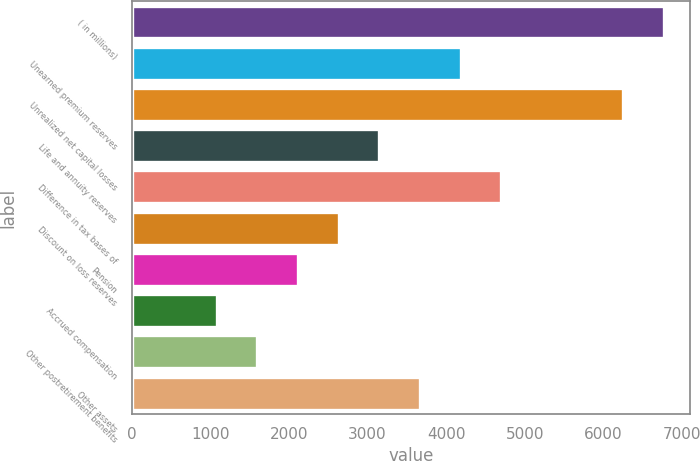<chart> <loc_0><loc_0><loc_500><loc_500><bar_chart><fcel>( in millions)<fcel>Unearned premium reserves<fcel>Unrealized net capital losses<fcel>Life and annuity reserves<fcel>Difference in tax bases of<fcel>Discount on loss reserves<fcel>Pension<fcel>Accrued compensation<fcel>Other postretirement benefits<fcel>Other assets<nl><fcel>6768.7<fcel>4184.2<fcel>6251.8<fcel>3150.4<fcel>4701.1<fcel>2633.5<fcel>2116.6<fcel>1082.8<fcel>1599.7<fcel>3667.3<nl></chart> 